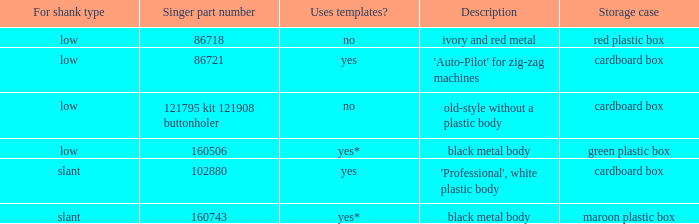Parse the full table. {'header': ['For shank type', 'Singer part number', 'Uses templates?', 'Description', 'Storage case'], 'rows': [['low', '86718', 'no', 'ivory and red metal', 'red plastic box'], ['low', '86721', 'yes', "'Auto-Pilot' for zig-zag machines", 'cardboard box'], ['low', '121795 kit 121908 buttonholer', 'no', 'old-style without a plastic body', 'cardboard box'], ['low', '160506', 'yes*', 'black metal body', 'green plastic box'], ['slant', '102880', 'yes', "'Professional', white plastic body", 'cardboard box'], ['slant', '160743', 'yes*', 'black metal body', 'maroon plastic box']]} What's the singer part number of the buttonholer whose storage case is a green plastic box? 160506.0. 